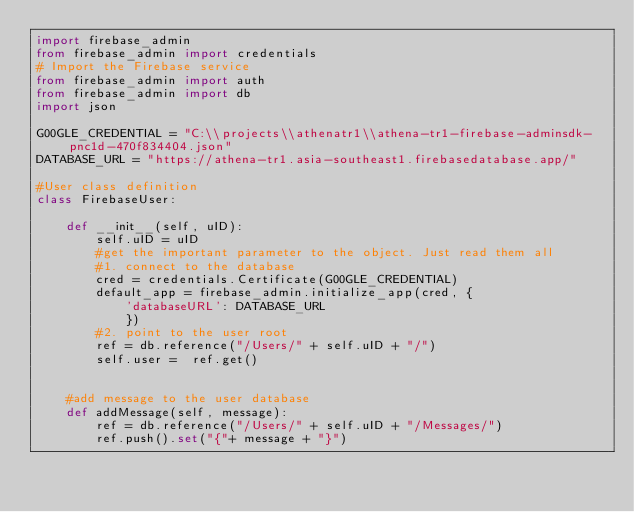Convert code to text. <code><loc_0><loc_0><loc_500><loc_500><_Python_>import firebase_admin
from firebase_admin import credentials
# Import the Firebase service
from firebase_admin import auth
from firebase_admin import db
import json

G00GLE_CREDENTIAL = "C:\\projects\\athenatr1\\athena-tr1-firebase-adminsdk-pnc1d-470f834404.json"
DATABASE_URL = "https://athena-tr1.asia-southeast1.firebasedatabase.app/"

#User class definition
class FirebaseUser:

    def __init__(self, uID):
        self.uID = uID
        #get the important parameter to the object. Just read them all
        #1. connect to the database
        cred = credentials.Certificate(G00GLE_CREDENTIAL)
        default_app = firebase_admin.initialize_app(cred, {
            'databaseURL': DATABASE_URL
            })
        #2. point to the user root
        ref = db.reference("/Users/" + self.uID + "/")
        self.user =  ref.get()


    #add message to the user database
    def addMessage(self, message):
        ref = db.reference("/Users/" + self.uID + "/Messages/")
        ref.push().set("{"+ message + "}")

</code> 